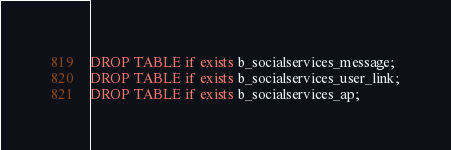<code> <loc_0><loc_0><loc_500><loc_500><_SQL_>DROP TABLE if exists b_socialservices_message;
DROP TABLE if exists b_socialservices_user_link;
DROP TABLE if exists b_socialservices_ap;</code> 